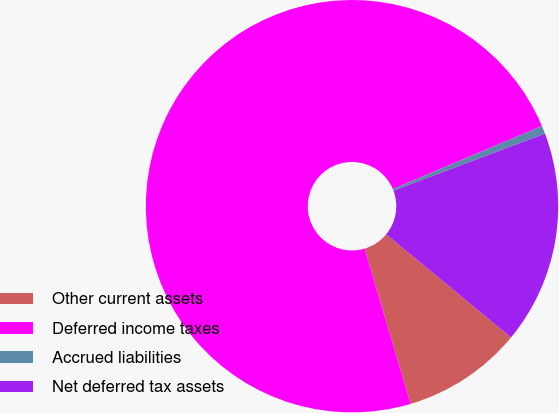Convert chart. <chart><loc_0><loc_0><loc_500><loc_500><pie_chart><fcel>Other current assets<fcel>Deferred income taxes<fcel>Accrued liabilities<fcel>Net deferred tax assets<nl><fcel>9.44%<fcel>73.23%<fcel>0.64%<fcel>16.7%<nl></chart> 